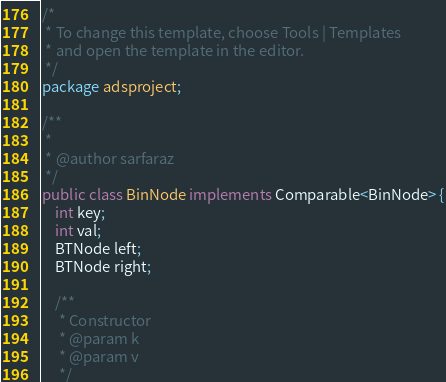<code> <loc_0><loc_0><loc_500><loc_500><_Java_>/*
 * To change this template, choose Tools | Templates
 * and open the template in the editor.
 */
package adsproject;

/**
 *
 * @author sarfaraz
 */
public class BinNode implements Comparable<BinNode> {
    int key;
    int val;
    BTNode left;
    BTNode right;
    
    /**
     * Constructor
     * @param k
     * @param v
     */</code> 